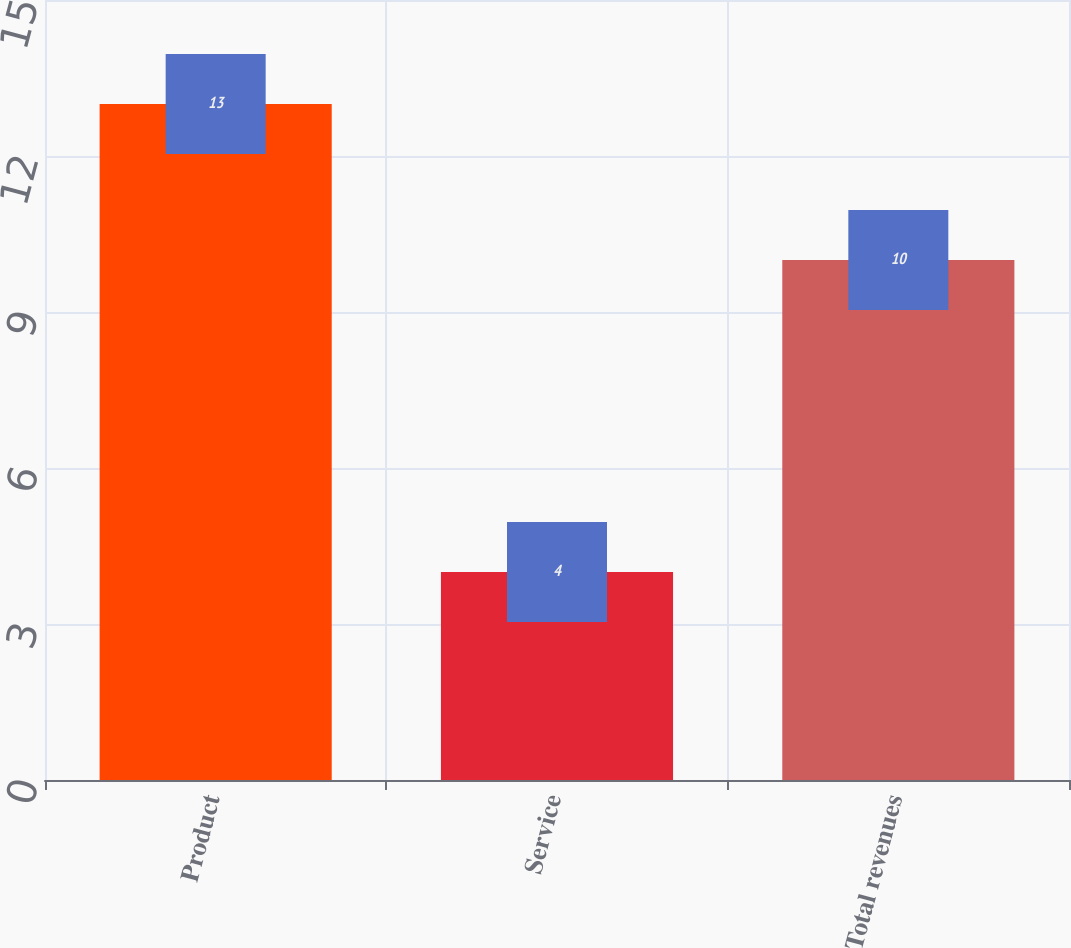Convert chart to OTSL. <chart><loc_0><loc_0><loc_500><loc_500><bar_chart><fcel>Product<fcel>Service<fcel>Total revenues<nl><fcel>13<fcel>4<fcel>10<nl></chart> 